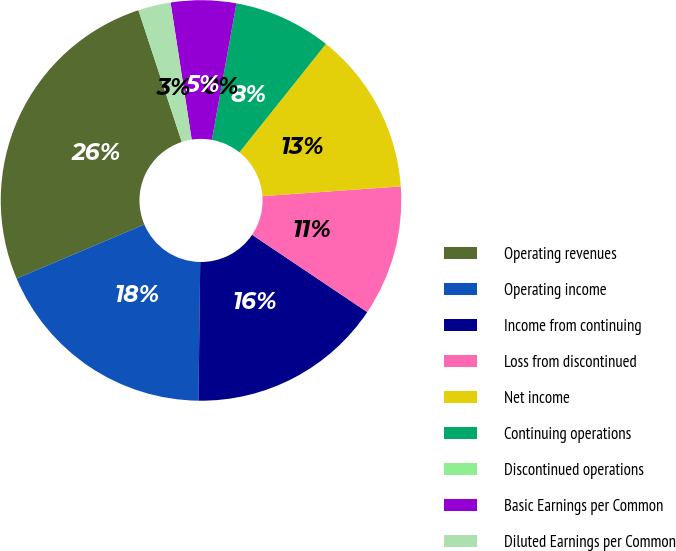<chart> <loc_0><loc_0><loc_500><loc_500><pie_chart><fcel>Operating revenues<fcel>Operating income<fcel>Income from continuing<fcel>Loss from discontinued<fcel>Net income<fcel>Continuing operations<fcel>Discontinued operations<fcel>Basic Earnings per Common<fcel>Diluted Earnings per Common<nl><fcel>26.32%<fcel>18.42%<fcel>15.79%<fcel>10.53%<fcel>13.16%<fcel>7.89%<fcel>0.0%<fcel>5.26%<fcel>2.63%<nl></chart> 